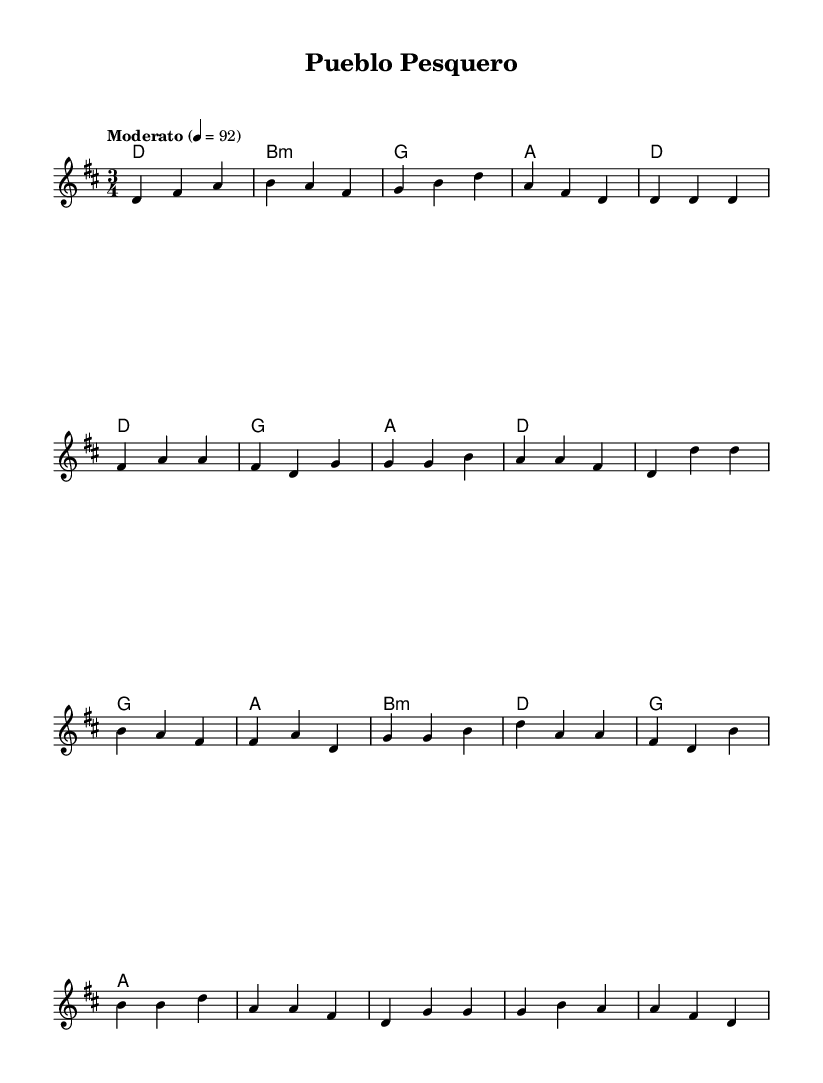What is the key signature of this music? The key signature is D major, which has two sharps (F# and C#).
Answer: D major What is the time signature of this music? The time signature is 3/4, indicating three beats per measure.
Answer: 3/4 What is the tempo marking of this piece? The tempo marking is "Moderato" with a metronome marking of 92 beats per minute.
Answer: Moderato How many measures are in the verse section? The verse section has four measures. This can be counted by looking at the notation for the verse labeled as "Verse 1."
Answer: 4 What chords are used in the bridge section? The chords used in the bridge are B minor, D, G, and A. This can be identified in the chord symbols written above the melody.
Answer: B minor, D, G, A What is the structure of the piece? The structure consists of an Intro, Verse, Chorus, and Bridge, as indicated by their respective labels.
Answer: Intro, Verse, Chorus, Bridge What is characteristic of the Latin acoustic ballads in the melody? The melody features a flowing, lyrical line with rhythmic emphasis typical of Latin ballads, evident through the melodic patterns and note values.
Answer: Flowing, lyrical line 